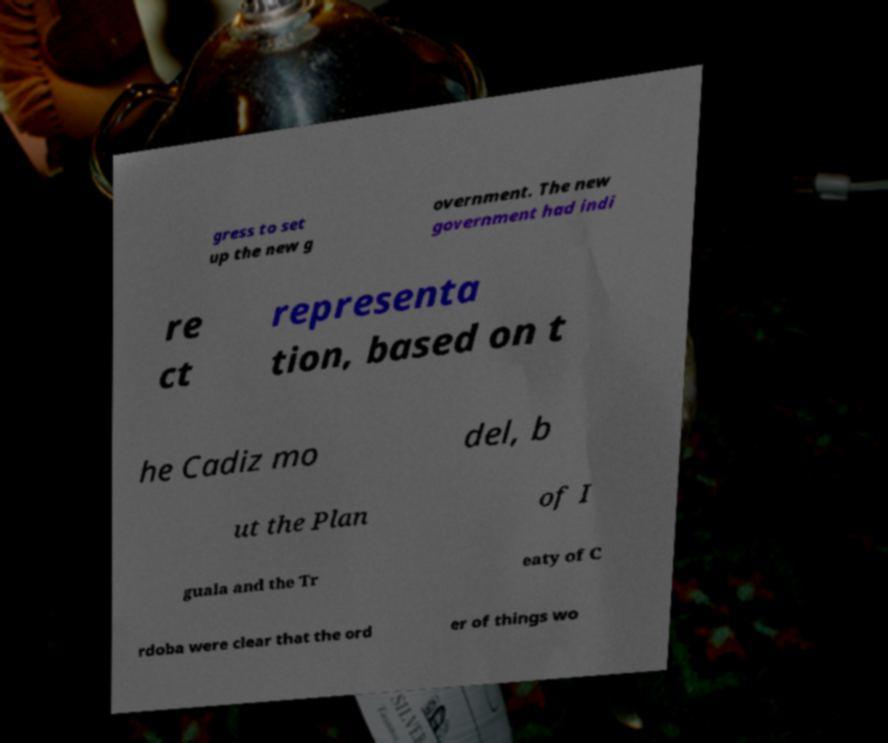I need the written content from this picture converted into text. Can you do that? gress to set up the new g overnment. The new government had indi re ct representa tion, based on t he Cadiz mo del, b ut the Plan of I guala and the Tr eaty of C rdoba were clear that the ord er of things wo 